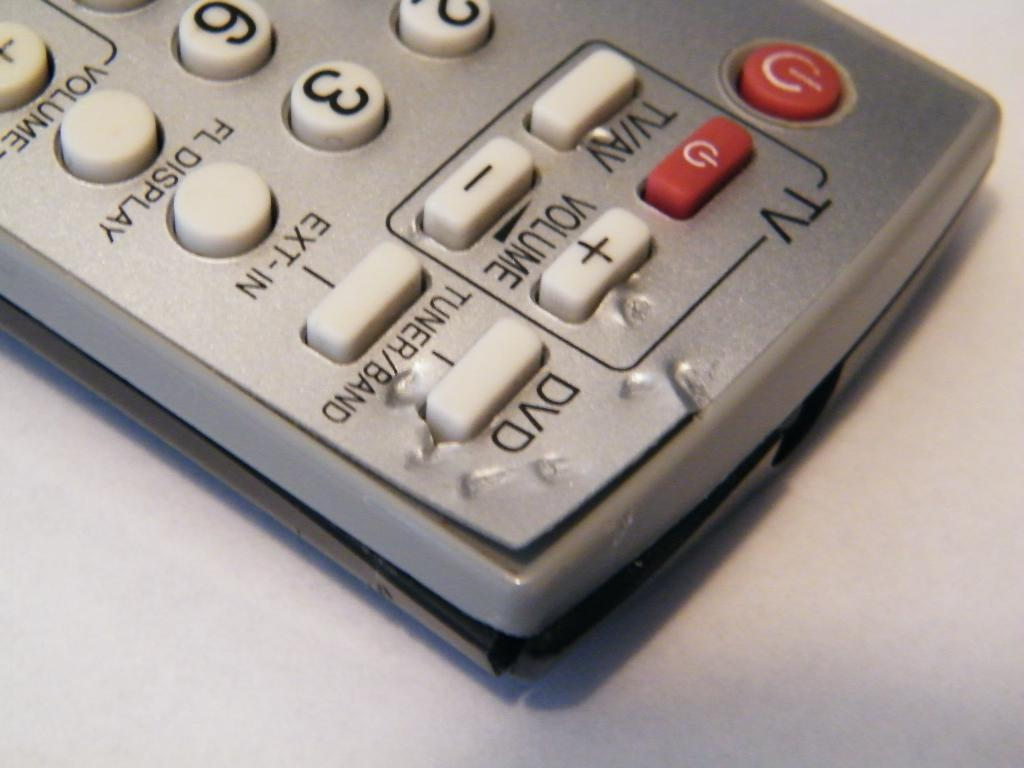Provide a one-sentence caption for the provided image. A silver remote that has buttons for TV and DVD. 